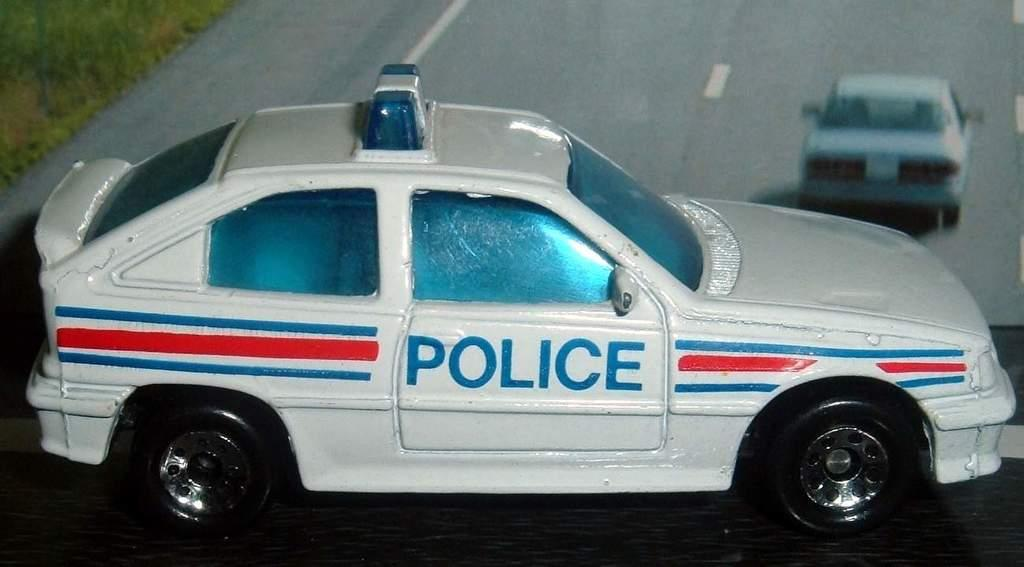What type of toy is present in the image? There is a white color police car toy in the image. What can be seen in the background of the image? There is a road poster in the background of the image. What type of war songs can be heard playing in the background of the image? There is no indication of any war songs or sounds in the image; it features a police car toy and a road poster. 